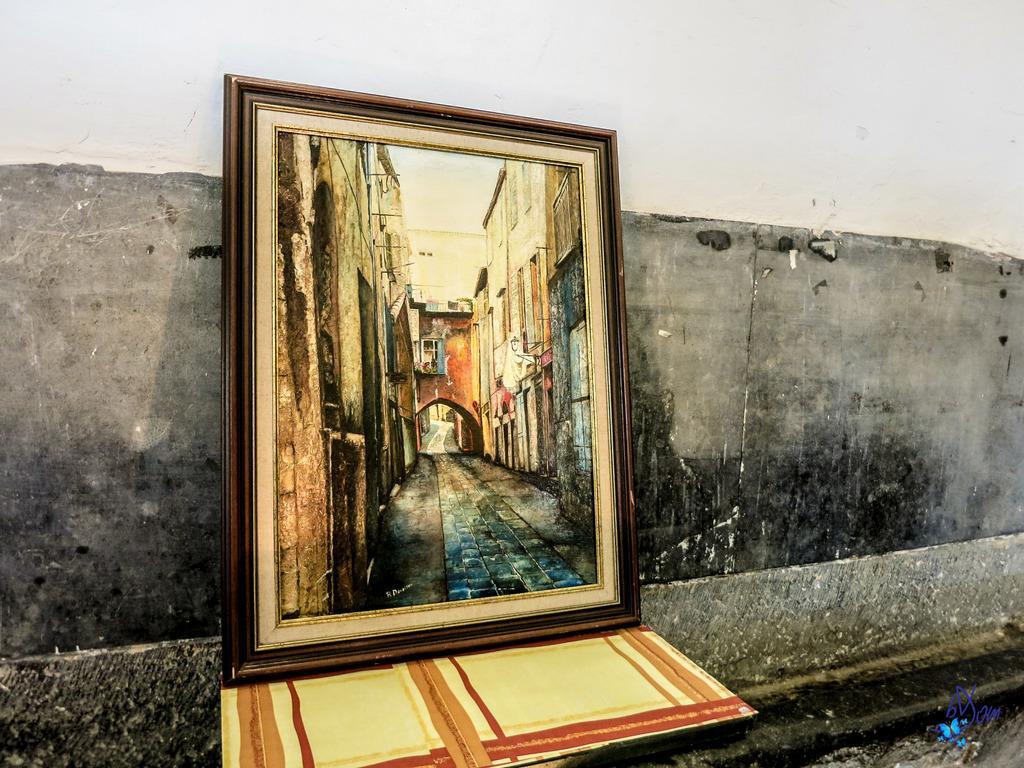How would you summarize this image in a sentence or two? In this image, we can see a wall, frame and a paper and we can see a logo. 